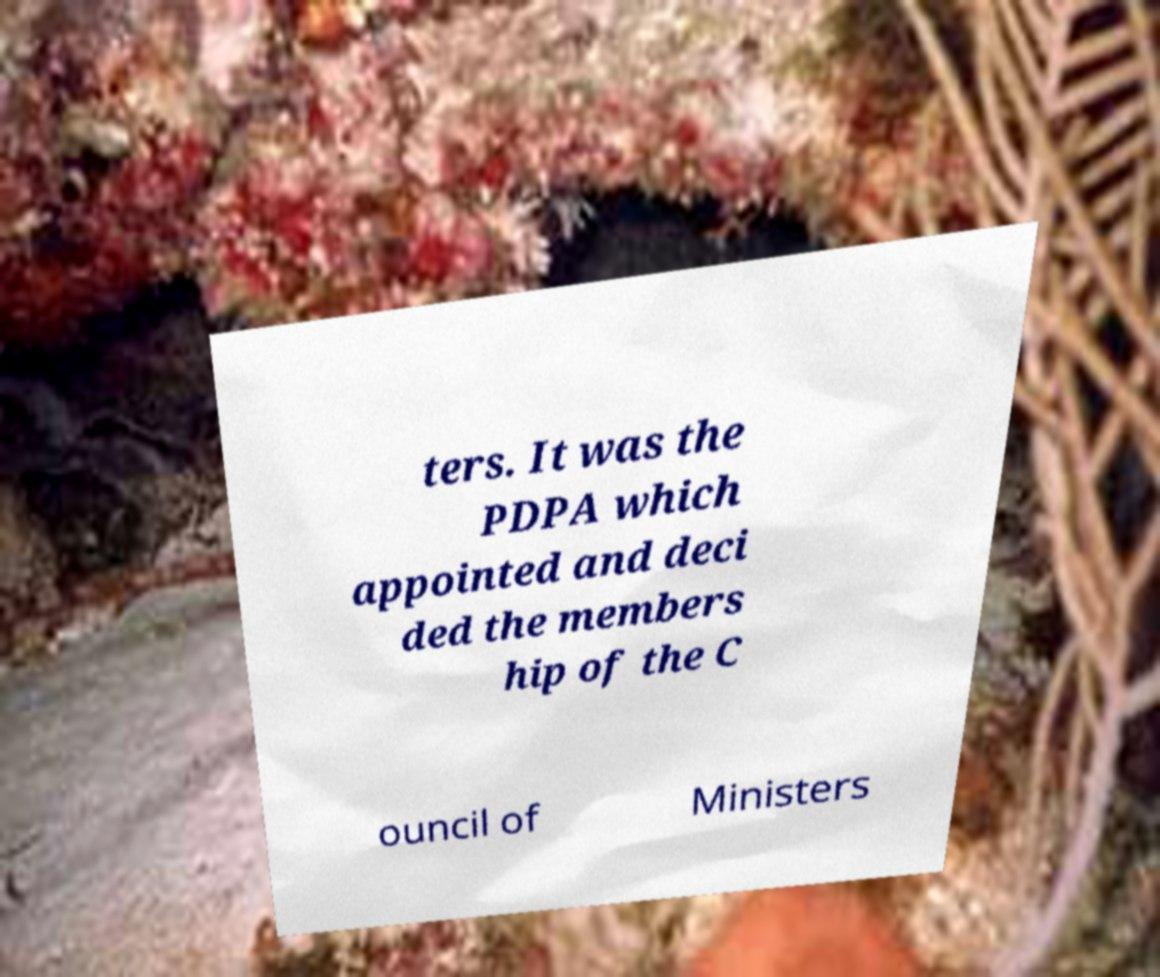Please read and relay the text visible in this image. What does it say? ters. It was the PDPA which appointed and deci ded the members hip of the C ouncil of Ministers 